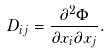Convert formula to latex. <formula><loc_0><loc_0><loc_500><loc_500>D _ { i j } = \frac { \partial ^ { 2 } \Phi } { \partial x _ { i } \partial x _ { j } } .</formula> 